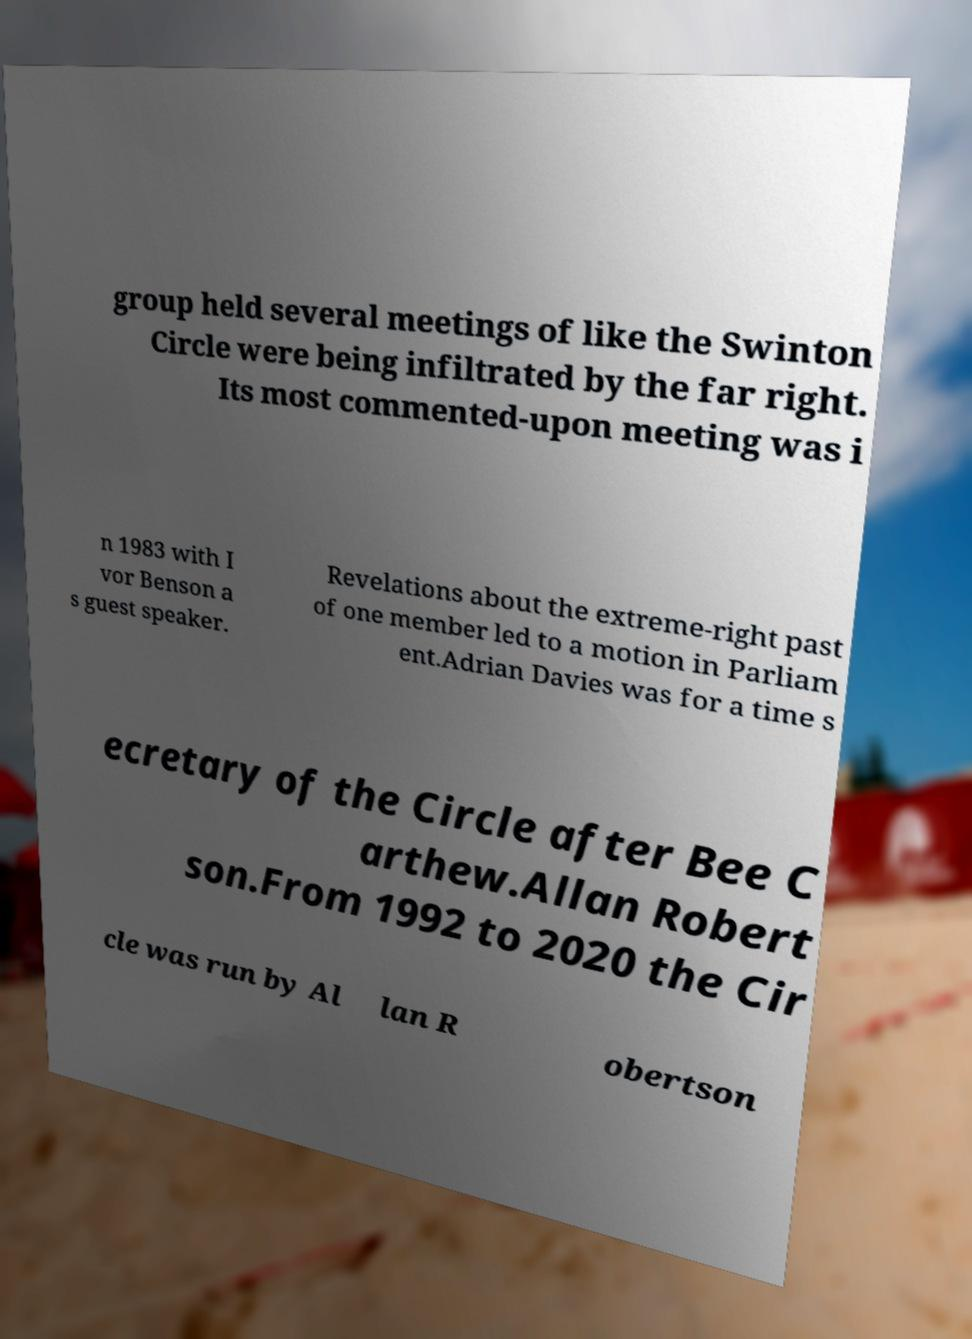For documentation purposes, I need the text within this image transcribed. Could you provide that? group held several meetings of like the Swinton Circle were being infiltrated by the far right. Its most commented-upon meeting was i n 1983 with I vor Benson a s guest speaker. Revelations about the extreme-right past of one member led to a motion in Parliam ent.Adrian Davies was for a time s ecretary of the Circle after Bee C arthew.Allan Robert son.From 1992 to 2020 the Cir cle was run by Al lan R obertson 